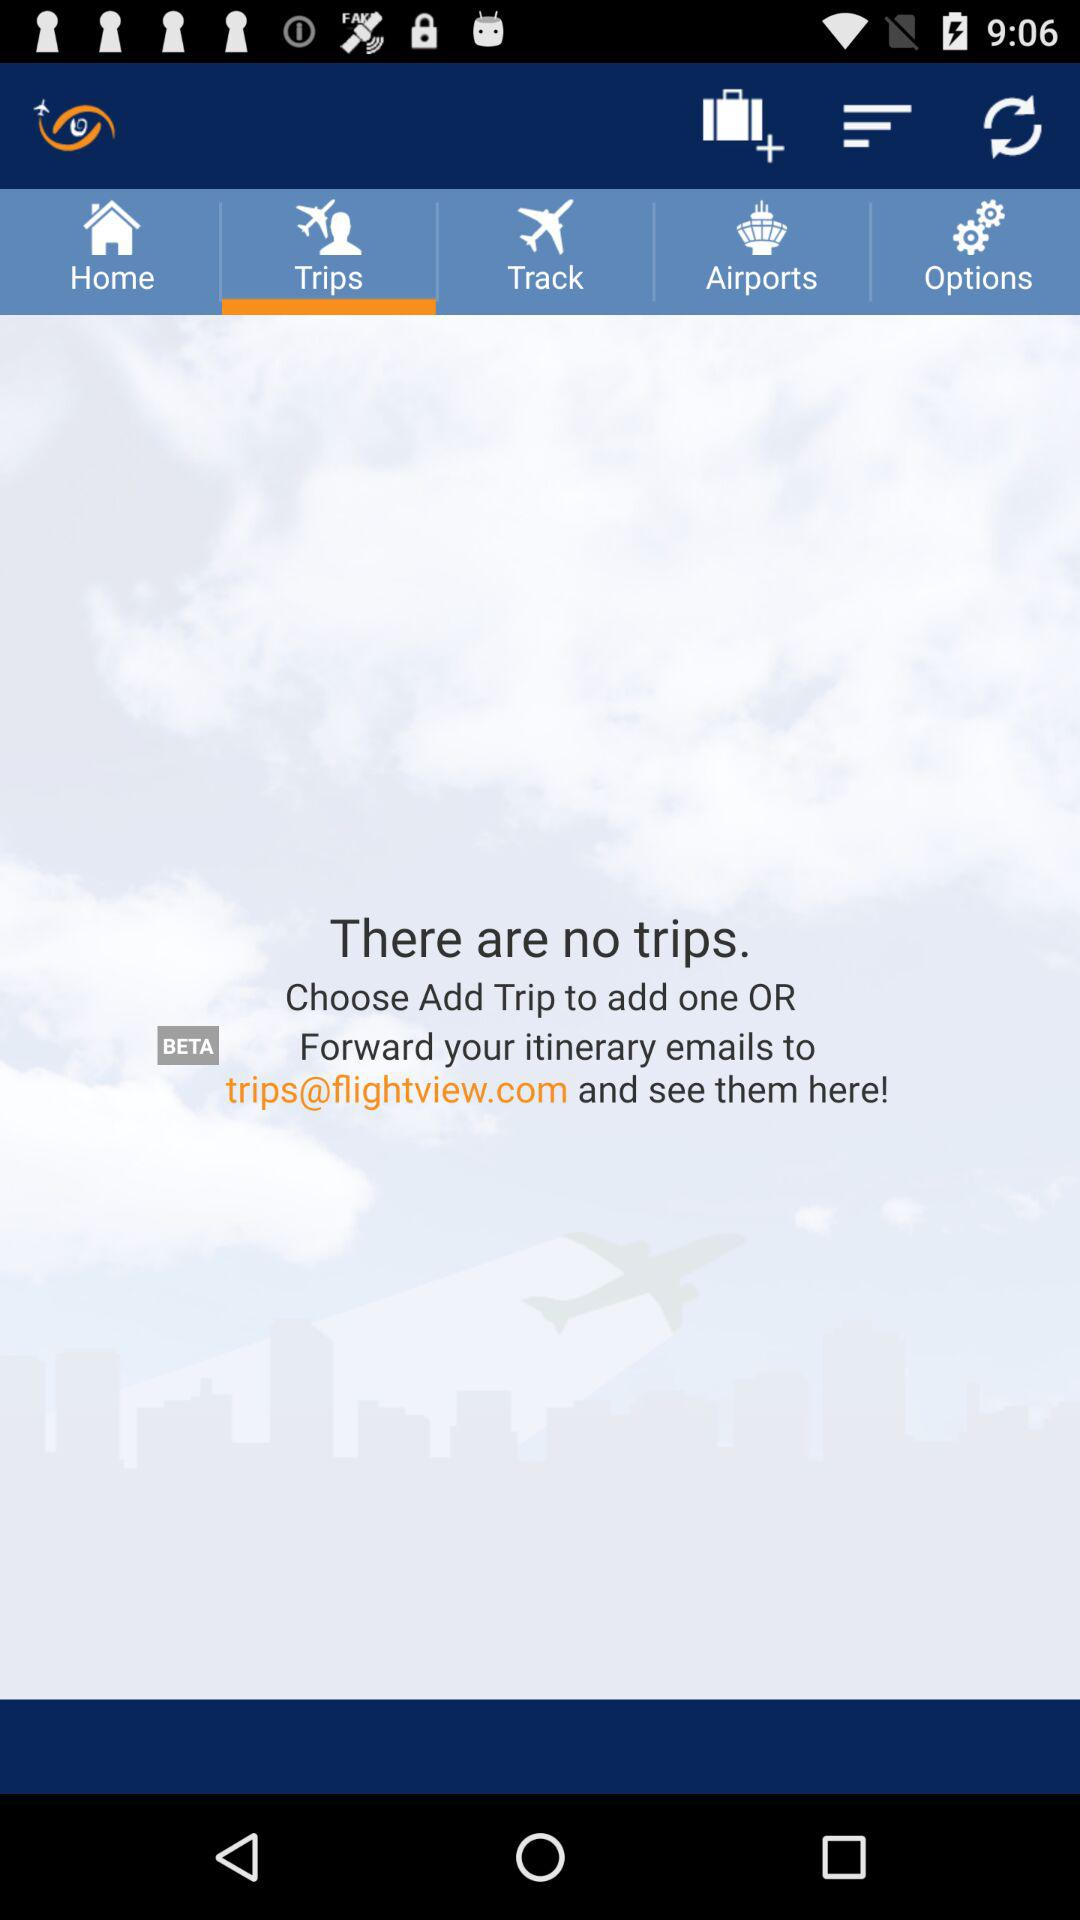Which tab is selected? The selected tab is "Trips". 